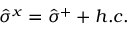Convert formula to latex. <formula><loc_0><loc_0><loc_500><loc_500>\hat { \sigma } ^ { x } = \hat { \sigma } ^ { + } + h . c .</formula> 